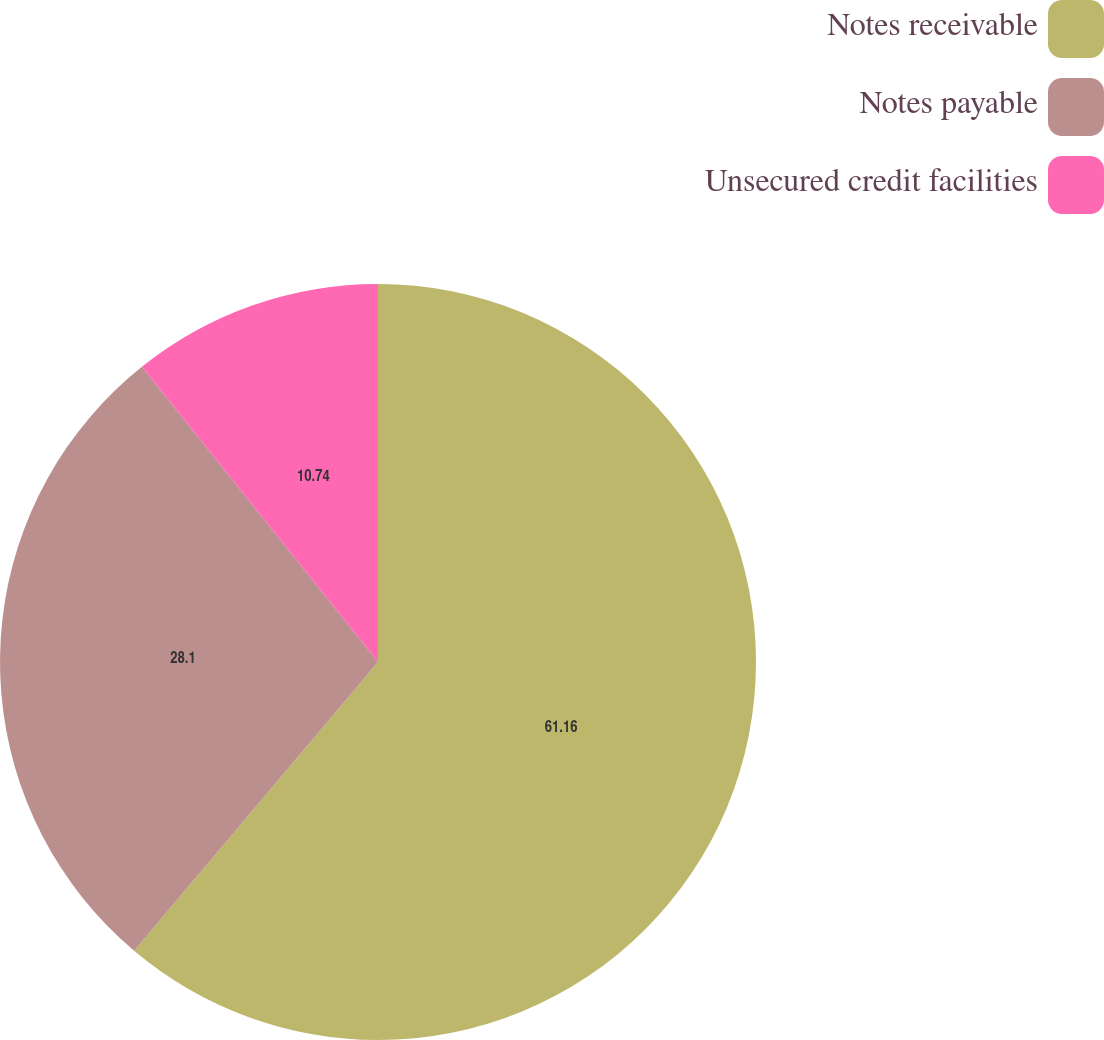Convert chart to OTSL. <chart><loc_0><loc_0><loc_500><loc_500><pie_chart><fcel>Notes receivable<fcel>Notes payable<fcel>Unsecured credit facilities<nl><fcel>61.16%<fcel>28.1%<fcel>10.74%<nl></chart> 